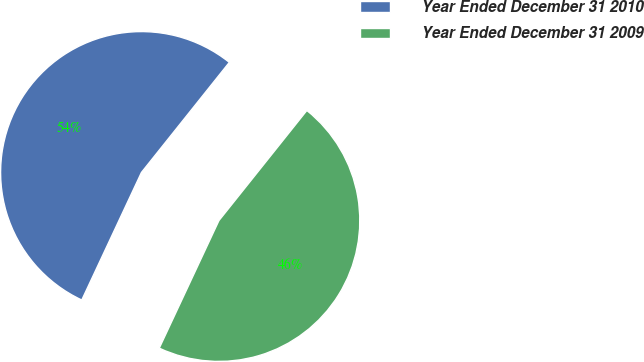Convert chart. <chart><loc_0><loc_0><loc_500><loc_500><pie_chart><fcel>Year Ended December 31 2010<fcel>Year Ended December 31 2009<nl><fcel>53.76%<fcel>46.24%<nl></chart> 